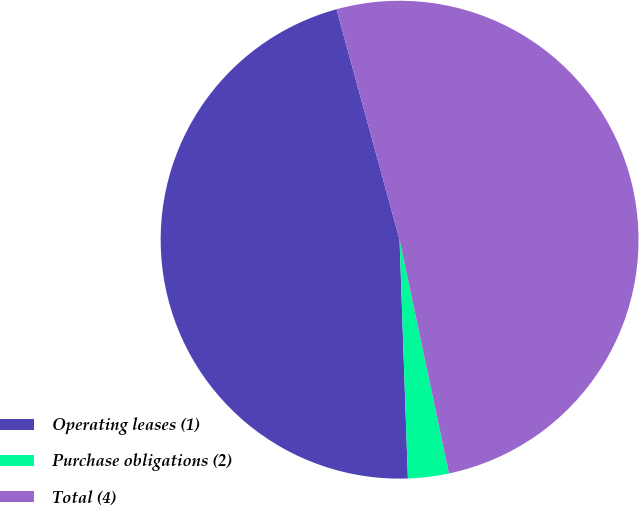Convert chart to OTSL. <chart><loc_0><loc_0><loc_500><loc_500><pie_chart><fcel>Operating leases (1)<fcel>Purchase obligations (2)<fcel>Total (4)<nl><fcel>46.3%<fcel>2.76%<fcel>50.93%<nl></chart> 